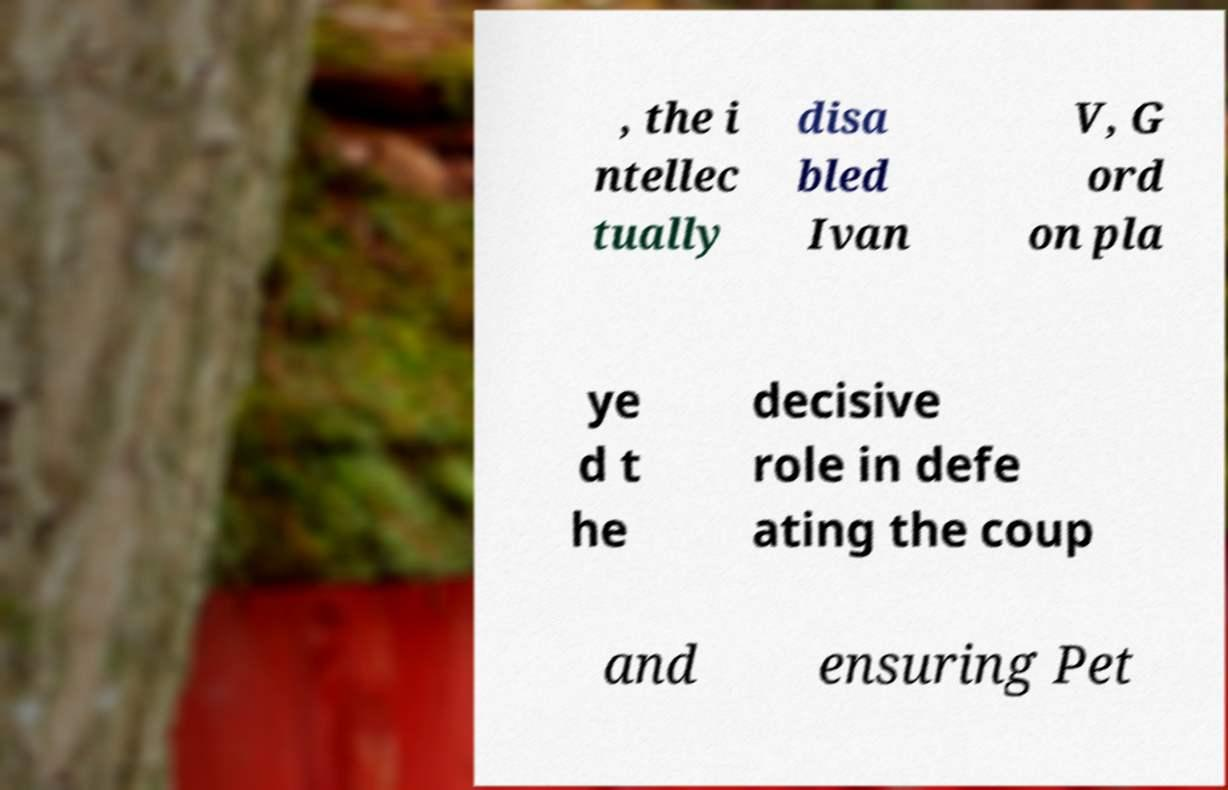Please identify and transcribe the text found in this image. , the i ntellec tually disa bled Ivan V, G ord on pla ye d t he decisive role in defe ating the coup and ensuring Pet 